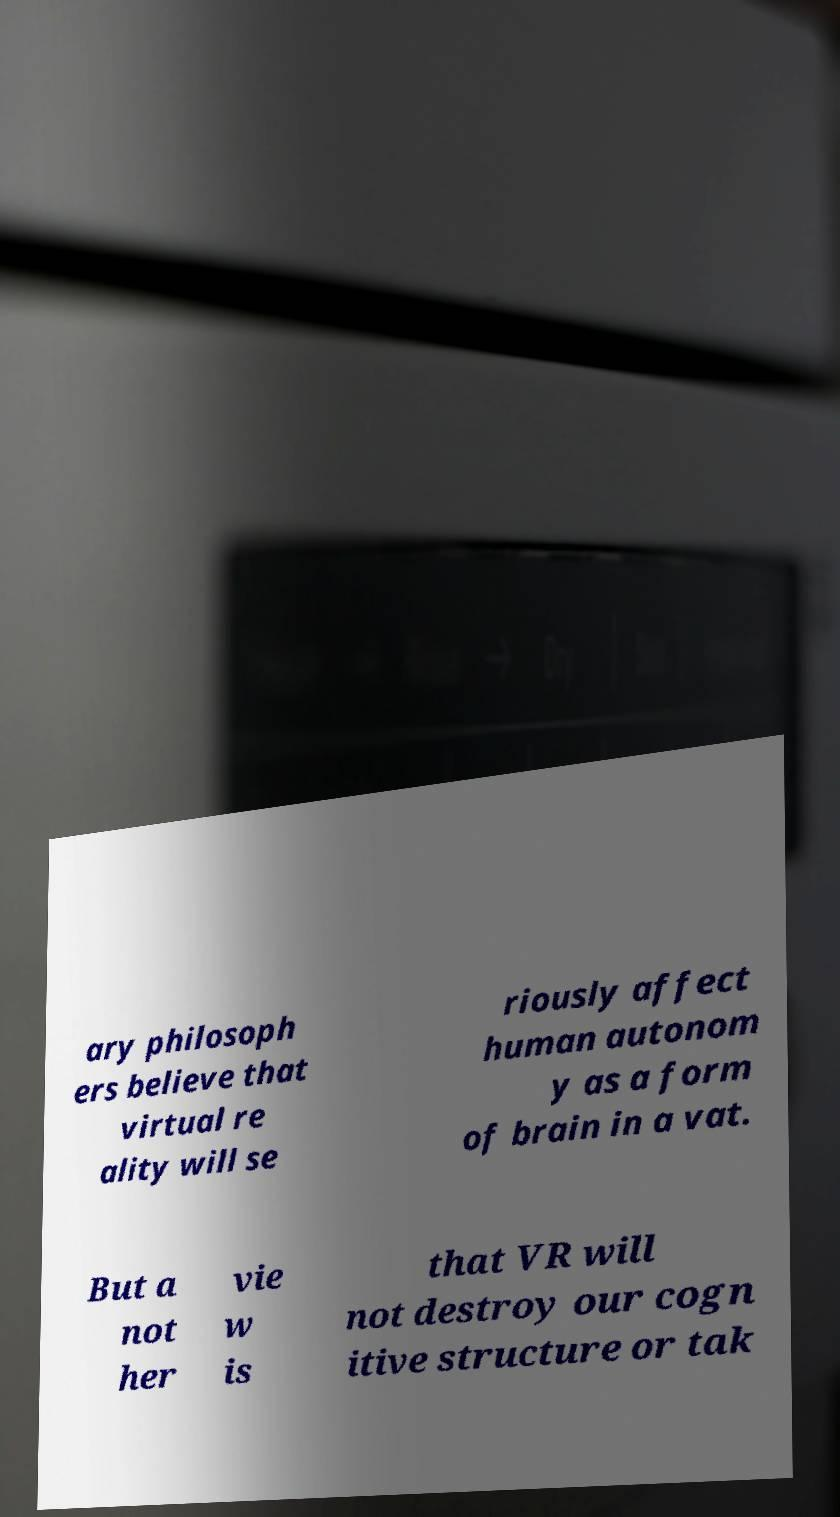Can you read and provide the text displayed in the image?This photo seems to have some interesting text. Can you extract and type it out for me? ary philosoph ers believe that virtual re ality will se riously affect human autonom y as a form of brain in a vat. But a not her vie w is that VR will not destroy our cogn itive structure or tak 